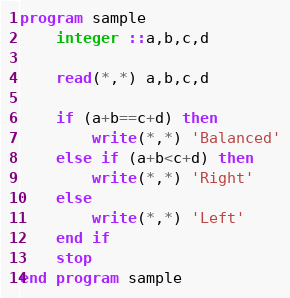<code> <loc_0><loc_0><loc_500><loc_500><_FORTRAN_>program sample
	integer ::a,b,c,d
    
    read(*,*) a,b,c,d
    
    if (a+b==c+d) then
    	write(*,*) 'Balanced'
    else if (a+b<c+d) then
    	write(*,*) 'Right'
    else
    	write(*,*) 'Left'
    end if
    stop
end program sample</code> 